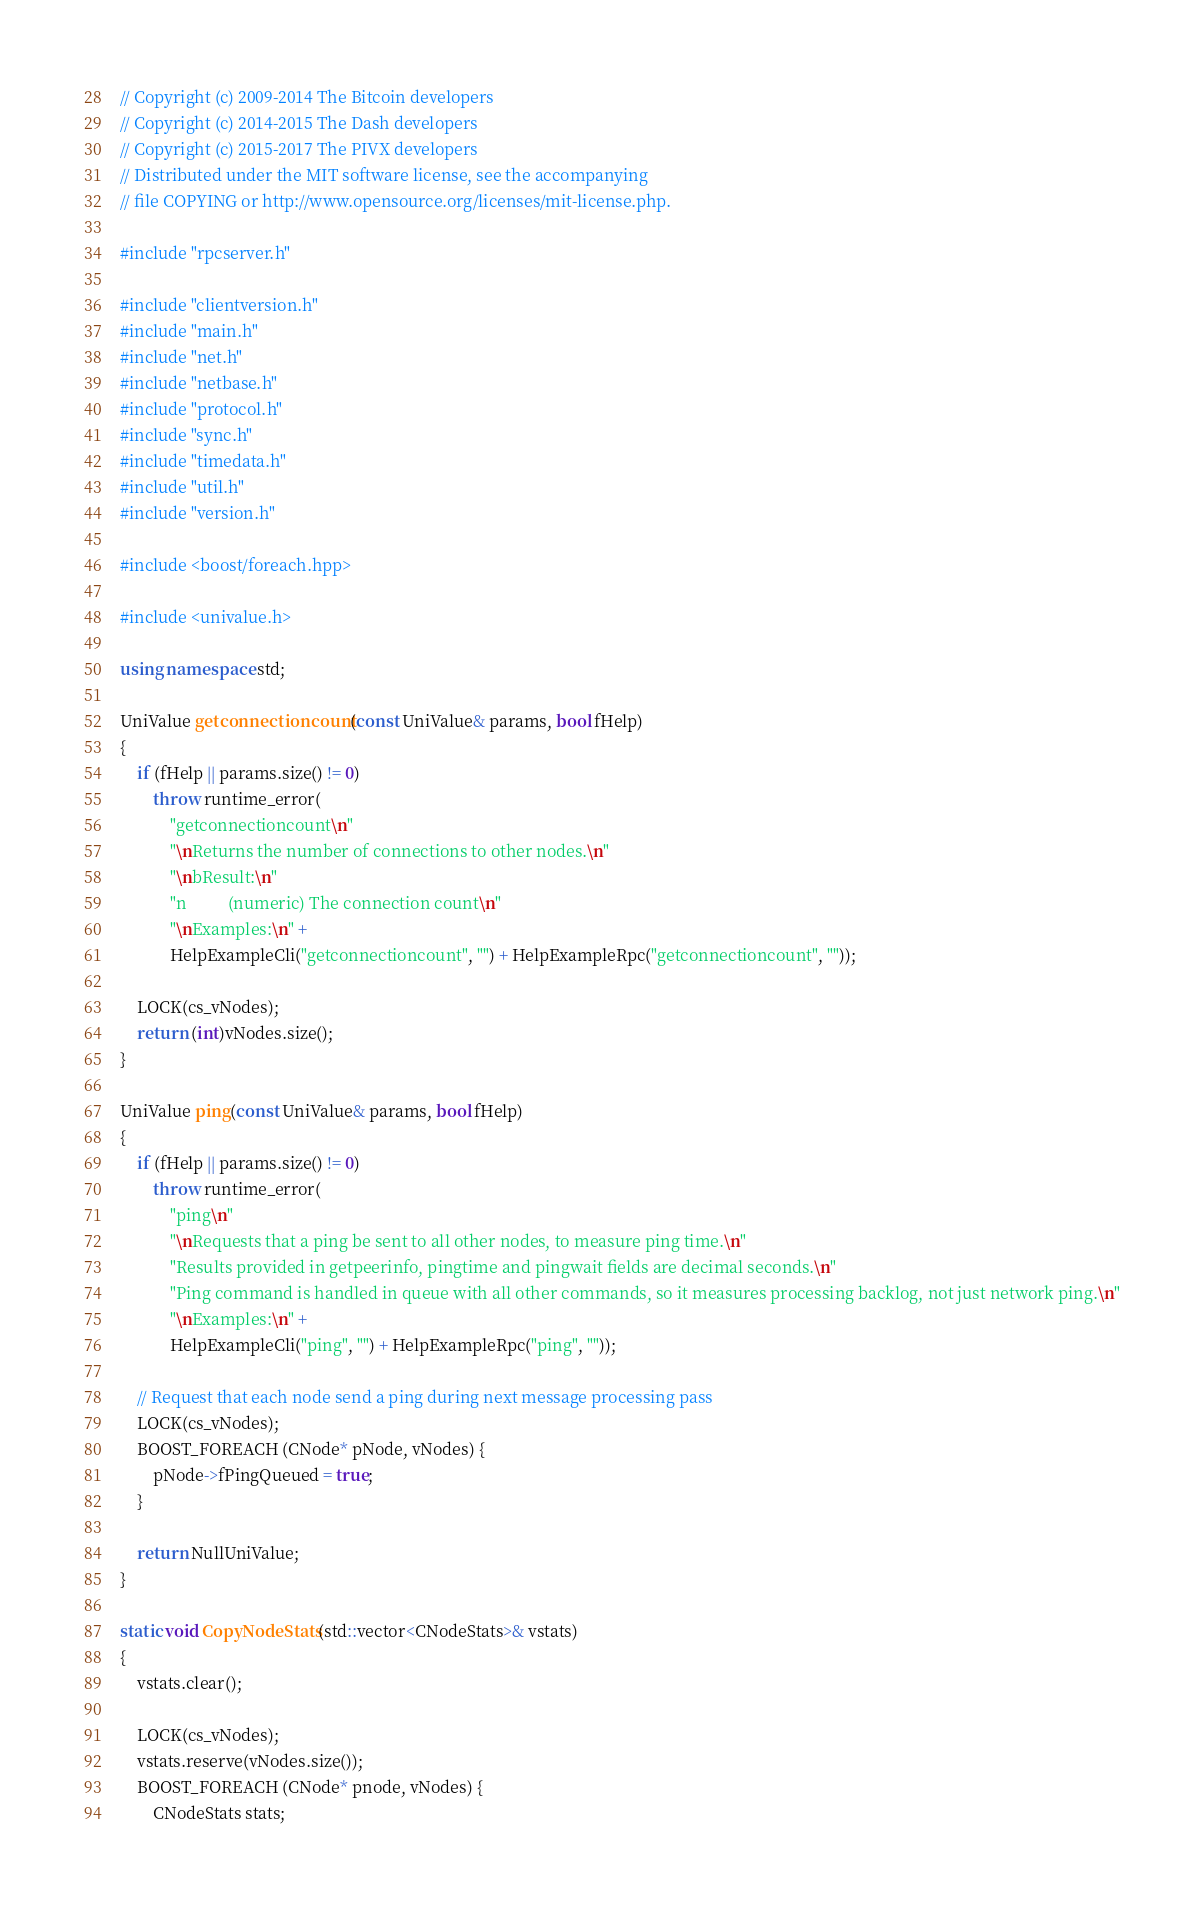Convert code to text. <code><loc_0><loc_0><loc_500><loc_500><_C++_>// Copyright (c) 2009-2014 The Bitcoin developers
// Copyright (c) 2014-2015 The Dash developers
// Copyright (c) 2015-2017 The PIVX developers
// Distributed under the MIT software license, see the accompanying
// file COPYING or http://www.opensource.org/licenses/mit-license.php.

#include "rpcserver.h"

#include "clientversion.h"
#include "main.h"
#include "net.h"
#include "netbase.h"
#include "protocol.h"
#include "sync.h"
#include "timedata.h"
#include "util.h"
#include "version.h"

#include <boost/foreach.hpp>

#include <univalue.h>

using namespace std;

UniValue getconnectioncount(const UniValue& params, bool fHelp)
{
    if (fHelp || params.size() != 0)
        throw runtime_error(
            "getconnectioncount\n"
            "\nReturns the number of connections to other nodes.\n"
            "\nbResult:\n"
            "n          (numeric) The connection count\n"
            "\nExamples:\n" +
            HelpExampleCli("getconnectioncount", "") + HelpExampleRpc("getconnectioncount", ""));

    LOCK(cs_vNodes);
    return (int)vNodes.size();
}

UniValue ping(const UniValue& params, bool fHelp)
{
    if (fHelp || params.size() != 0)
        throw runtime_error(
            "ping\n"
            "\nRequests that a ping be sent to all other nodes, to measure ping time.\n"
            "Results provided in getpeerinfo, pingtime and pingwait fields are decimal seconds.\n"
            "Ping command is handled in queue with all other commands, so it measures processing backlog, not just network ping.\n"
            "\nExamples:\n" +
            HelpExampleCli("ping", "") + HelpExampleRpc("ping", ""));

    // Request that each node send a ping during next message processing pass
    LOCK(cs_vNodes);
    BOOST_FOREACH (CNode* pNode, vNodes) {
        pNode->fPingQueued = true;
    }

    return NullUniValue;
}

static void CopyNodeStats(std::vector<CNodeStats>& vstats)
{
    vstats.clear();

    LOCK(cs_vNodes);
    vstats.reserve(vNodes.size());
    BOOST_FOREACH (CNode* pnode, vNodes) {
        CNodeStats stats;</code> 